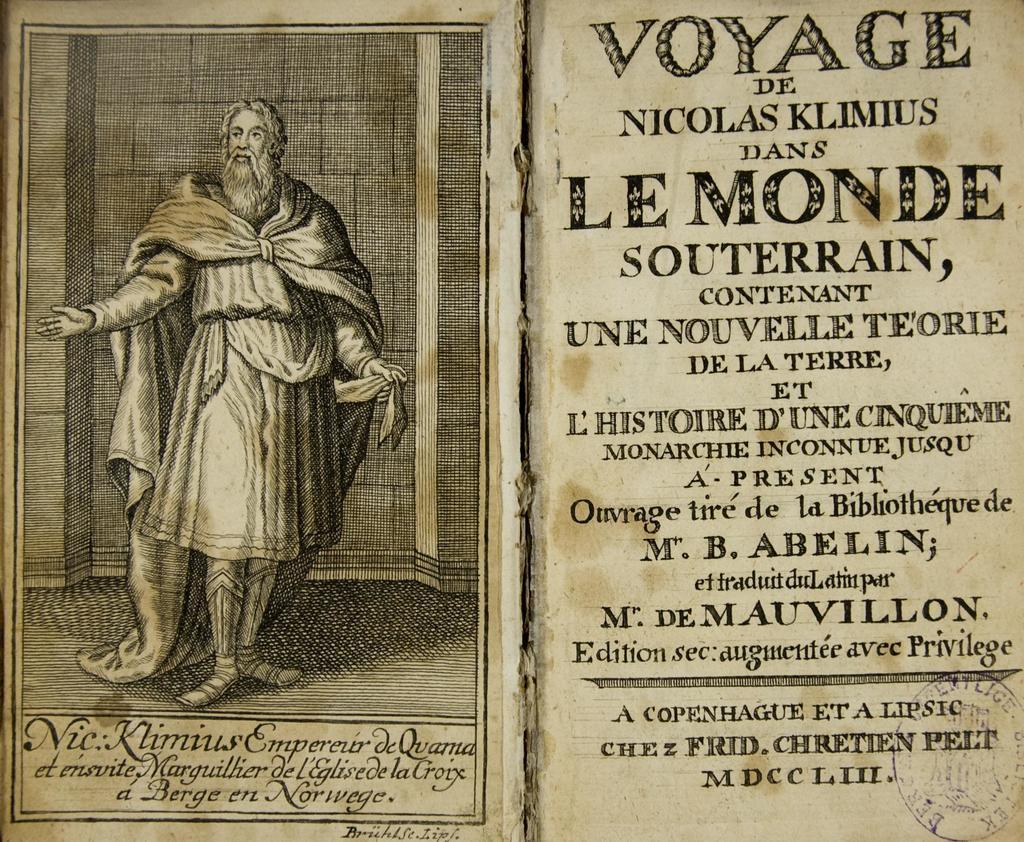How would you summarize this image in a sentence or two? This is the picture of a book. On the left side of the image there is a picture of a person standing. At the bottom there is a text. On the right side of the image there is a text and there is a stamp on the paper. 